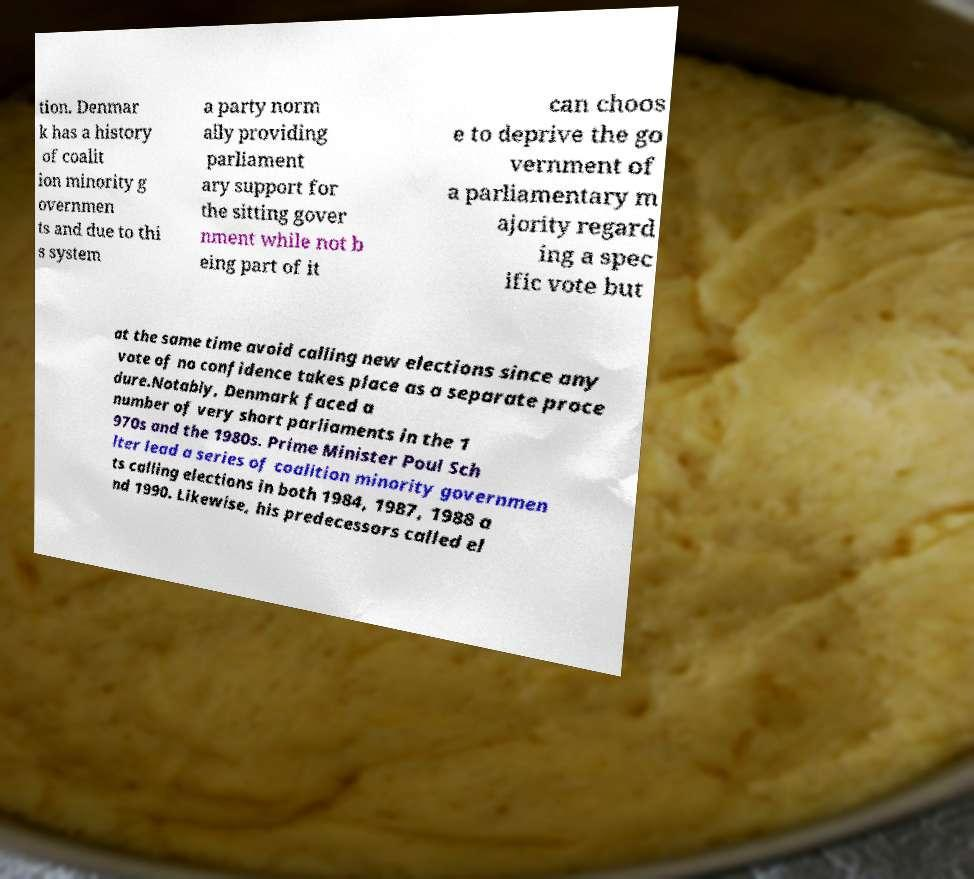Can you accurately transcribe the text from the provided image for me? tion. Denmar k has a history of coalit ion minority g overnmen ts and due to thi s system a party norm ally providing parliament ary support for the sitting gover nment while not b eing part of it can choos e to deprive the go vernment of a parliamentary m ajority regard ing a spec ific vote but at the same time avoid calling new elections since any vote of no confidence takes place as a separate proce dure.Notably, Denmark faced a number of very short parliaments in the 1 970s and the 1980s. Prime Minister Poul Sch lter lead a series of coalition minority governmen ts calling elections in both 1984, 1987, 1988 a nd 1990. Likewise, his predecessors called el 